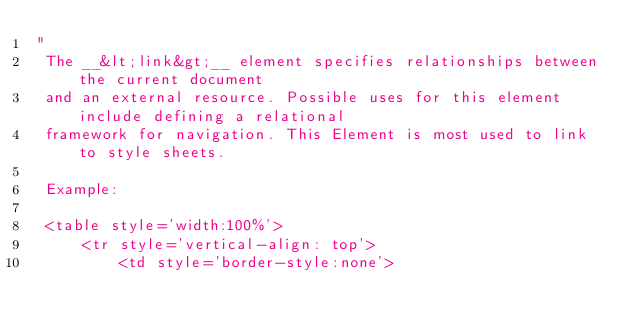<code> <loc_0><loc_0><loc_500><loc_500><_Ceylon_>"
 The __&lt;link&gt;__ element specifies relationships between the current document  
 and an external resource. Possible uses for this element include defining a relational 
 framework for navigation. This Element is most used to link to style sheets.
 
 Example:
 
 <table style='width:100%'>
     <tr style='vertical-align: top'>
         <td style='border-style:none'>
         </code> 